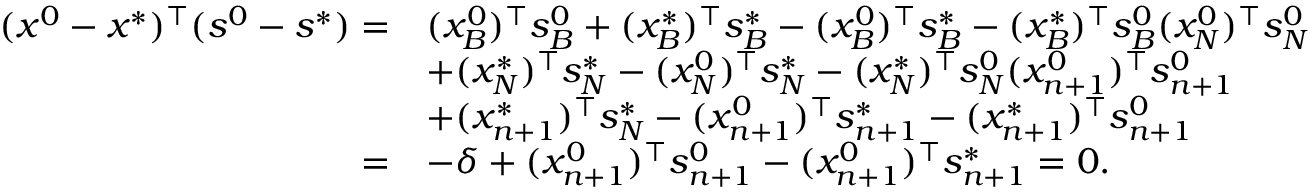Convert formula to latex. <formula><loc_0><loc_0><loc_500><loc_500>\begin{array} { r l } { ( x ^ { 0 } - x ^ { * } ) ^ { \top } ( s ^ { 0 } - s ^ { * } ) = } & { ( x _ { B } ^ { 0 } ) ^ { \top } s _ { B } ^ { 0 } + ( x _ { B } ^ { * } ) ^ { \top } s _ { B } ^ { * } - ( x _ { B } ^ { 0 } ) ^ { \top } s _ { B } ^ { * } - ( x _ { B } ^ { * } ) ^ { \top } s _ { B } ^ { 0 } ( x _ { N } ^ { 0 } ) ^ { \top } s _ { N } ^ { 0 } } \\ & { + ( x _ { N } ^ { * } ) ^ { \top } s _ { N } ^ { * } - ( x _ { N } ^ { 0 } ) ^ { \top } s _ { N } ^ { * } - ( x _ { N } ^ { * } ) ^ { \top } s _ { N } ^ { 0 } ( x _ { n + 1 } ^ { 0 } ) ^ { \top } s _ { n + 1 } ^ { 0 } } \\ & { + ( x _ { n + 1 } ^ { * } ) ^ { \top } s _ { N } ^ { * } - ( x _ { n + 1 } ^ { 0 } ) ^ { \top } s _ { n + 1 } ^ { * } - ( x _ { n + 1 } ^ { * } ) ^ { \top } s _ { n + 1 } ^ { 0 } } \\ { = } & { - \delta + ( x _ { n + 1 } ^ { 0 } ) ^ { \top } s _ { n + 1 } ^ { 0 } - ( x _ { n + 1 } ^ { 0 } ) ^ { \top } s _ { n + 1 } ^ { * } = 0 . } \end{array}</formula> 